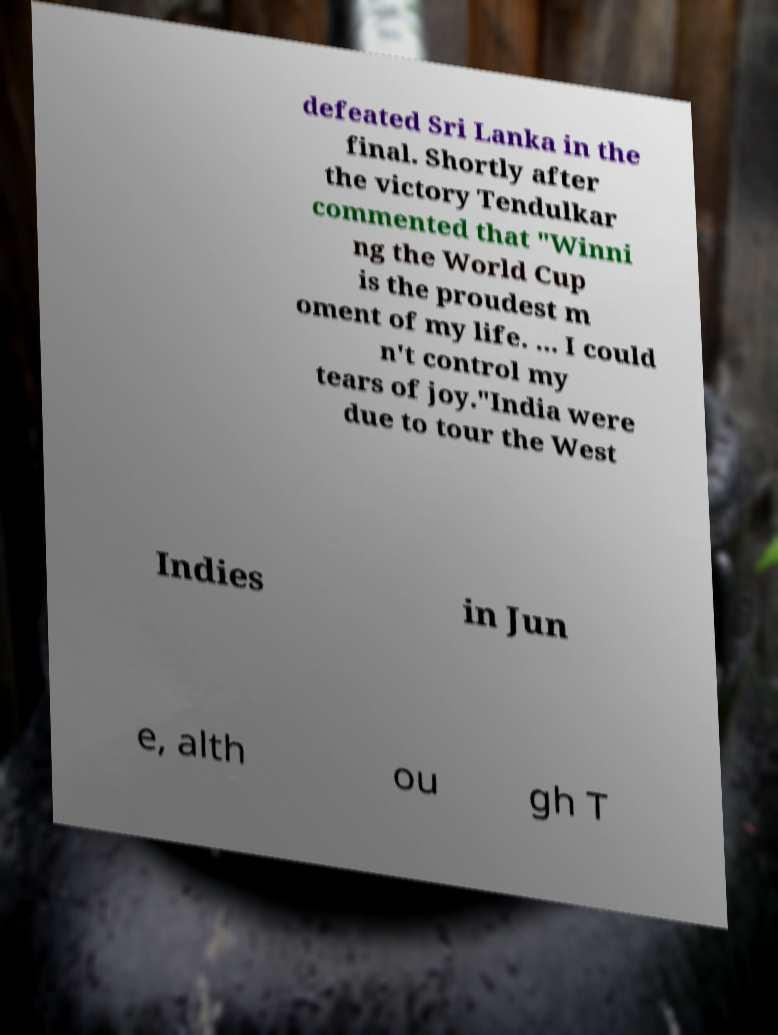There's text embedded in this image that I need extracted. Can you transcribe it verbatim? defeated Sri Lanka in the final. Shortly after the victory Tendulkar commented that "Winni ng the World Cup is the proudest m oment of my life. ... I could n't control my tears of joy."India were due to tour the West Indies in Jun e, alth ou gh T 